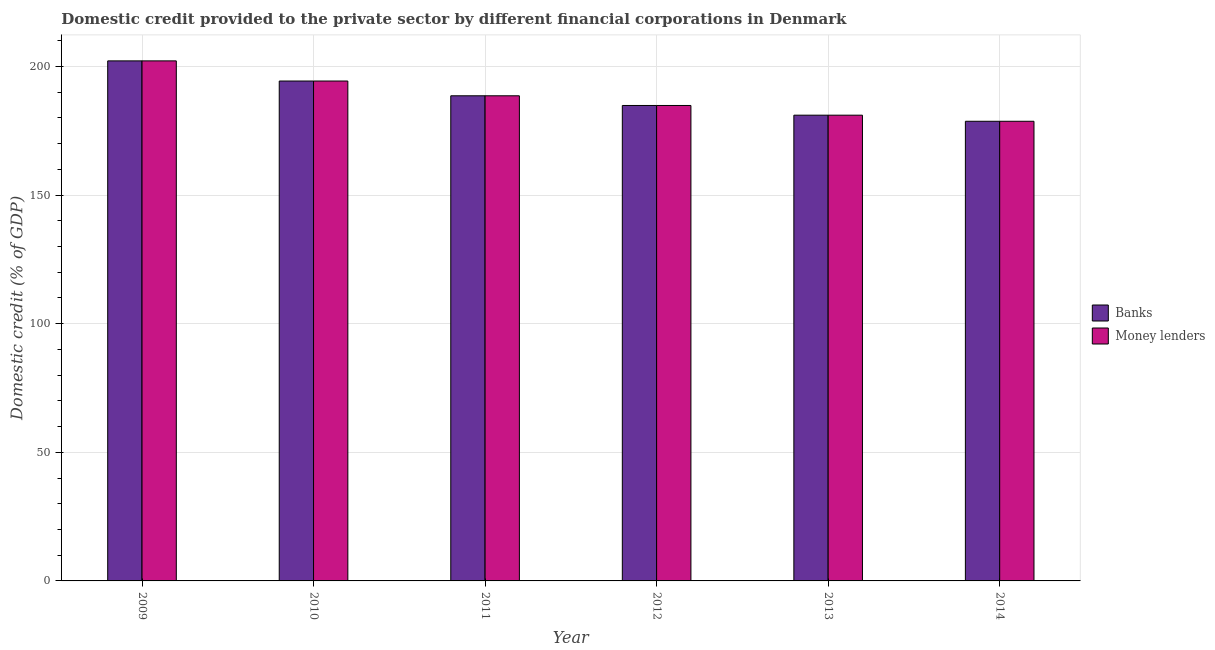How many different coloured bars are there?
Ensure brevity in your answer.  2. How many groups of bars are there?
Make the answer very short. 6. What is the label of the 3rd group of bars from the left?
Your answer should be compact. 2011. What is the domestic credit provided by money lenders in 2014?
Provide a succinct answer. 178.71. Across all years, what is the maximum domestic credit provided by money lenders?
Make the answer very short. 202.19. Across all years, what is the minimum domestic credit provided by banks?
Provide a short and direct response. 178.71. In which year was the domestic credit provided by money lenders minimum?
Your response must be concise. 2014. What is the total domestic credit provided by banks in the graph?
Give a very brief answer. 1129.79. What is the difference between the domestic credit provided by money lenders in 2009 and that in 2013?
Your answer should be very brief. 21.11. What is the difference between the domestic credit provided by money lenders in 2012 and the domestic credit provided by banks in 2014?
Give a very brief answer. 6.14. What is the average domestic credit provided by banks per year?
Give a very brief answer. 188.3. In how many years, is the domestic credit provided by money lenders greater than 180 %?
Your answer should be very brief. 5. What is the ratio of the domestic credit provided by banks in 2011 to that in 2012?
Offer a very short reply. 1.02. Is the domestic credit provided by banks in 2009 less than that in 2014?
Keep it short and to the point. No. Is the difference between the domestic credit provided by banks in 2010 and 2012 greater than the difference between the domestic credit provided by money lenders in 2010 and 2012?
Keep it short and to the point. No. What is the difference between the highest and the second highest domestic credit provided by money lenders?
Offer a terse response. 7.83. What is the difference between the highest and the lowest domestic credit provided by banks?
Keep it short and to the point. 23.48. Is the sum of the domestic credit provided by money lenders in 2010 and 2014 greater than the maximum domestic credit provided by banks across all years?
Provide a succinct answer. Yes. What does the 2nd bar from the left in 2010 represents?
Offer a very short reply. Money lenders. What does the 1st bar from the right in 2011 represents?
Offer a very short reply. Money lenders. How many years are there in the graph?
Your answer should be compact. 6. Does the graph contain any zero values?
Your answer should be compact. No. Does the graph contain grids?
Offer a terse response. Yes. Where does the legend appear in the graph?
Provide a short and direct response. Center right. How many legend labels are there?
Offer a very short reply. 2. How are the legend labels stacked?
Your response must be concise. Vertical. What is the title of the graph?
Offer a terse response. Domestic credit provided to the private sector by different financial corporations in Denmark. What is the label or title of the Y-axis?
Your answer should be compact. Domestic credit (% of GDP). What is the Domestic credit (% of GDP) in Banks in 2009?
Offer a very short reply. 202.19. What is the Domestic credit (% of GDP) of Money lenders in 2009?
Keep it short and to the point. 202.19. What is the Domestic credit (% of GDP) in Banks in 2010?
Offer a very short reply. 194.36. What is the Domestic credit (% of GDP) of Money lenders in 2010?
Your answer should be very brief. 194.36. What is the Domestic credit (% of GDP) of Banks in 2011?
Offer a terse response. 188.61. What is the Domestic credit (% of GDP) of Money lenders in 2011?
Your answer should be compact. 188.61. What is the Domestic credit (% of GDP) in Banks in 2012?
Your answer should be very brief. 184.85. What is the Domestic credit (% of GDP) of Money lenders in 2012?
Your answer should be compact. 184.85. What is the Domestic credit (% of GDP) in Banks in 2013?
Make the answer very short. 181.07. What is the Domestic credit (% of GDP) of Money lenders in 2013?
Give a very brief answer. 181.08. What is the Domestic credit (% of GDP) in Banks in 2014?
Give a very brief answer. 178.71. What is the Domestic credit (% of GDP) of Money lenders in 2014?
Offer a very short reply. 178.71. Across all years, what is the maximum Domestic credit (% of GDP) in Banks?
Make the answer very short. 202.19. Across all years, what is the maximum Domestic credit (% of GDP) of Money lenders?
Your answer should be compact. 202.19. Across all years, what is the minimum Domestic credit (% of GDP) in Banks?
Your response must be concise. 178.71. Across all years, what is the minimum Domestic credit (% of GDP) of Money lenders?
Provide a short and direct response. 178.71. What is the total Domestic credit (% of GDP) of Banks in the graph?
Your answer should be compact. 1129.79. What is the total Domestic credit (% of GDP) of Money lenders in the graph?
Provide a succinct answer. 1129.8. What is the difference between the Domestic credit (% of GDP) in Banks in 2009 and that in 2010?
Ensure brevity in your answer.  7.83. What is the difference between the Domestic credit (% of GDP) of Money lenders in 2009 and that in 2010?
Provide a succinct answer. 7.83. What is the difference between the Domestic credit (% of GDP) in Banks in 2009 and that in 2011?
Offer a terse response. 13.57. What is the difference between the Domestic credit (% of GDP) in Money lenders in 2009 and that in 2011?
Offer a terse response. 13.57. What is the difference between the Domestic credit (% of GDP) of Banks in 2009 and that in 2012?
Your response must be concise. 17.34. What is the difference between the Domestic credit (% of GDP) of Money lenders in 2009 and that in 2012?
Your response must be concise. 17.34. What is the difference between the Domestic credit (% of GDP) in Banks in 2009 and that in 2013?
Provide a short and direct response. 21.11. What is the difference between the Domestic credit (% of GDP) of Money lenders in 2009 and that in 2013?
Make the answer very short. 21.11. What is the difference between the Domestic credit (% of GDP) of Banks in 2009 and that in 2014?
Offer a very short reply. 23.48. What is the difference between the Domestic credit (% of GDP) in Money lenders in 2009 and that in 2014?
Your response must be concise. 23.48. What is the difference between the Domestic credit (% of GDP) in Banks in 2010 and that in 2011?
Provide a succinct answer. 5.74. What is the difference between the Domestic credit (% of GDP) in Money lenders in 2010 and that in 2011?
Make the answer very short. 5.74. What is the difference between the Domestic credit (% of GDP) in Banks in 2010 and that in 2012?
Offer a very short reply. 9.51. What is the difference between the Domestic credit (% of GDP) in Money lenders in 2010 and that in 2012?
Ensure brevity in your answer.  9.51. What is the difference between the Domestic credit (% of GDP) of Banks in 2010 and that in 2013?
Give a very brief answer. 13.28. What is the difference between the Domestic credit (% of GDP) of Money lenders in 2010 and that in 2013?
Make the answer very short. 13.28. What is the difference between the Domestic credit (% of GDP) of Banks in 2010 and that in 2014?
Provide a short and direct response. 15.65. What is the difference between the Domestic credit (% of GDP) in Money lenders in 2010 and that in 2014?
Provide a short and direct response. 15.65. What is the difference between the Domestic credit (% of GDP) in Banks in 2011 and that in 2012?
Your answer should be very brief. 3.77. What is the difference between the Domestic credit (% of GDP) of Money lenders in 2011 and that in 2012?
Offer a very short reply. 3.77. What is the difference between the Domestic credit (% of GDP) in Banks in 2011 and that in 2013?
Offer a terse response. 7.54. What is the difference between the Domestic credit (% of GDP) of Money lenders in 2011 and that in 2013?
Your answer should be very brief. 7.54. What is the difference between the Domestic credit (% of GDP) in Banks in 2011 and that in 2014?
Give a very brief answer. 9.91. What is the difference between the Domestic credit (% of GDP) in Money lenders in 2011 and that in 2014?
Your answer should be compact. 9.91. What is the difference between the Domestic credit (% of GDP) of Banks in 2012 and that in 2013?
Provide a short and direct response. 3.77. What is the difference between the Domestic credit (% of GDP) in Money lenders in 2012 and that in 2013?
Your answer should be compact. 3.77. What is the difference between the Domestic credit (% of GDP) of Banks in 2012 and that in 2014?
Your response must be concise. 6.14. What is the difference between the Domestic credit (% of GDP) in Money lenders in 2012 and that in 2014?
Provide a succinct answer. 6.14. What is the difference between the Domestic credit (% of GDP) of Banks in 2013 and that in 2014?
Your response must be concise. 2.37. What is the difference between the Domestic credit (% of GDP) of Money lenders in 2013 and that in 2014?
Provide a succinct answer. 2.37. What is the difference between the Domestic credit (% of GDP) of Banks in 2009 and the Domestic credit (% of GDP) of Money lenders in 2010?
Offer a terse response. 7.83. What is the difference between the Domestic credit (% of GDP) in Banks in 2009 and the Domestic credit (% of GDP) in Money lenders in 2011?
Provide a short and direct response. 13.57. What is the difference between the Domestic credit (% of GDP) of Banks in 2009 and the Domestic credit (% of GDP) of Money lenders in 2012?
Your answer should be compact. 17.34. What is the difference between the Domestic credit (% of GDP) of Banks in 2009 and the Domestic credit (% of GDP) of Money lenders in 2013?
Offer a very short reply. 21.11. What is the difference between the Domestic credit (% of GDP) of Banks in 2009 and the Domestic credit (% of GDP) of Money lenders in 2014?
Your answer should be very brief. 23.48. What is the difference between the Domestic credit (% of GDP) of Banks in 2010 and the Domestic credit (% of GDP) of Money lenders in 2011?
Give a very brief answer. 5.74. What is the difference between the Domestic credit (% of GDP) in Banks in 2010 and the Domestic credit (% of GDP) in Money lenders in 2012?
Give a very brief answer. 9.51. What is the difference between the Domestic credit (% of GDP) in Banks in 2010 and the Domestic credit (% of GDP) in Money lenders in 2013?
Ensure brevity in your answer.  13.28. What is the difference between the Domestic credit (% of GDP) in Banks in 2010 and the Domestic credit (% of GDP) in Money lenders in 2014?
Give a very brief answer. 15.65. What is the difference between the Domestic credit (% of GDP) in Banks in 2011 and the Domestic credit (% of GDP) in Money lenders in 2012?
Your response must be concise. 3.77. What is the difference between the Domestic credit (% of GDP) of Banks in 2011 and the Domestic credit (% of GDP) of Money lenders in 2013?
Provide a short and direct response. 7.54. What is the difference between the Domestic credit (% of GDP) of Banks in 2011 and the Domestic credit (% of GDP) of Money lenders in 2014?
Provide a succinct answer. 9.91. What is the difference between the Domestic credit (% of GDP) of Banks in 2012 and the Domestic credit (% of GDP) of Money lenders in 2013?
Keep it short and to the point. 3.77. What is the difference between the Domestic credit (% of GDP) in Banks in 2012 and the Domestic credit (% of GDP) in Money lenders in 2014?
Provide a succinct answer. 6.14. What is the difference between the Domestic credit (% of GDP) in Banks in 2013 and the Domestic credit (% of GDP) in Money lenders in 2014?
Offer a very short reply. 2.37. What is the average Domestic credit (% of GDP) in Banks per year?
Make the answer very short. 188.3. What is the average Domestic credit (% of GDP) in Money lenders per year?
Ensure brevity in your answer.  188.3. In the year 2009, what is the difference between the Domestic credit (% of GDP) in Banks and Domestic credit (% of GDP) in Money lenders?
Ensure brevity in your answer.  -0. In the year 2010, what is the difference between the Domestic credit (% of GDP) in Banks and Domestic credit (% of GDP) in Money lenders?
Ensure brevity in your answer.  -0. In the year 2011, what is the difference between the Domestic credit (% of GDP) in Banks and Domestic credit (% of GDP) in Money lenders?
Offer a terse response. -0. In the year 2012, what is the difference between the Domestic credit (% of GDP) of Banks and Domestic credit (% of GDP) of Money lenders?
Provide a succinct answer. -0. In the year 2013, what is the difference between the Domestic credit (% of GDP) in Banks and Domestic credit (% of GDP) in Money lenders?
Make the answer very short. -0. In the year 2014, what is the difference between the Domestic credit (% of GDP) in Banks and Domestic credit (% of GDP) in Money lenders?
Keep it short and to the point. -0. What is the ratio of the Domestic credit (% of GDP) in Banks in 2009 to that in 2010?
Your answer should be very brief. 1.04. What is the ratio of the Domestic credit (% of GDP) in Money lenders in 2009 to that in 2010?
Your answer should be very brief. 1.04. What is the ratio of the Domestic credit (% of GDP) in Banks in 2009 to that in 2011?
Offer a terse response. 1.07. What is the ratio of the Domestic credit (% of GDP) of Money lenders in 2009 to that in 2011?
Provide a succinct answer. 1.07. What is the ratio of the Domestic credit (% of GDP) in Banks in 2009 to that in 2012?
Offer a very short reply. 1.09. What is the ratio of the Domestic credit (% of GDP) in Money lenders in 2009 to that in 2012?
Give a very brief answer. 1.09. What is the ratio of the Domestic credit (% of GDP) in Banks in 2009 to that in 2013?
Offer a terse response. 1.12. What is the ratio of the Domestic credit (% of GDP) of Money lenders in 2009 to that in 2013?
Ensure brevity in your answer.  1.12. What is the ratio of the Domestic credit (% of GDP) of Banks in 2009 to that in 2014?
Provide a succinct answer. 1.13. What is the ratio of the Domestic credit (% of GDP) in Money lenders in 2009 to that in 2014?
Ensure brevity in your answer.  1.13. What is the ratio of the Domestic credit (% of GDP) in Banks in 2010 to that in 2011?
Your answer should be very brief. 1.03. What is the ratio of the Domestic credit (% of GDP) of Money lenders in 2010 to that in 2011?
Offer a terse response. 1.03. What is the ratio of the Domestic credit (% of GDP) of Banks in 2010 to that in 2012?
Offer a terse response. 1.05. What is the ratio of the Domestic credit (% of GDP) in Money lenders in 2010 to that in 2012?
Provide a short and direct response. 1.05. What is the ratio of the Domestic credit (% of GDP) in Banks in 2010 to that in 2013?
Provide a short and direct response. 1.07. What is the ratio of the Domestic credit (% of GDP) in Money lenders in 2010 to that in 2013?
Provide a succinct answer. 1.07. What is the ratio of the Domestic credit (% of GDP) of Banks in 2010 to that in 2014?
Give a very brief answer. 1.09. What is the ratio of the Domestic credit (% of GDP) in Money lenders in 2010 to that in 2014?
Give a very brief answer. 1.09. What is the ratio of the Domestic credit (% of GDP) in Banks in 2011 to that in 2012?
Make the answer very short. 1.02. What is the ratio of the Domestic credit (% of GDP) of Money lenders in 2011 to that in 2012?
Your answer should be very brief. 1.02. What is the ratio of the Domestic credit (% of GDP) in Banks in 2011 to that in 2013?
Offer a terse response. 1.04. What is the ratio of the Domestic credit (% of GDP) of Money lenders in 2011 to that in 2013?
Your response must be concise. 1.04. What is the ratio of the Domestic credit (% of GDP) of Banks in 2011 to that in 2014?
Keep it short and to the point. 1.06. What is the ratio of the Domestic credit (% of GDP) of Money lenders in 2011 to that in 2014?
Give a very brief answer. 1.06. What is the ratio of the Domestic credit (% of GDP) of Banks in 2012 to that in 2013?
Give a very brief answer. 1.02. What is the ratio of the Domestic credit (% of GDP) of Money lenders in 2012 to that in 2013?
Offer a terse response. 1.02. What is the ratio of the Domestic credit (% of GDP) in Banks in 2012 to that in 2014?
Make the answer very short. 1.03. What is the ratio of the Domestic credit (% of GDP) in Money lenders in 2012 to that in 2014?
Offer a terse response. 1.03. What is the ratio of the Domestic credit (% of GDP) in Banks in 2013 to that in 2014?
Your answer should be compact. 1.01. What is the ratio of the Domestic credit (% of GDP) of Money lenders in 2013 to that in 2014?
Your answer should be compact. 1.01. What is the difference between the highest and the second highest Domestic credit (% of GDP) of Banks?
Keep it short and to the point. 7.83. What is the difference between the highest and the second highest Domestic credit (% of GDP) of Money lenders?
Offer a terse response. 7.83. What is the difference between the highest and the lowest Domestic credit (% of GDP) in Banks?
Provide a short and direct response. 23.48. What is the difference between the highest and the lowest Domestic credit (% of GDP) in Money lenders?
Ensure brevity in your answer.  23.48. 